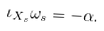Convert formula to latex. <formula><loc_0><loc_0><loc_500><loc_500>\iota _ { X _ { s } } \omega _ { s } = - \alpha .</formula> 